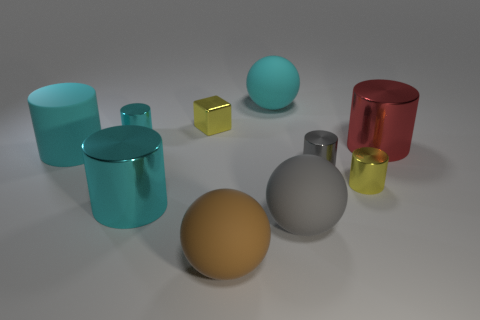There is a sphere that is on the left side of the cyan matte sphere; is its size the same as the small gray object? The sphere on the left side of the cyan matte sphere is larger than the small gray object. Specifically, the small gray object appears to be a cube, and while it's challenging to compare objects of different shapes directly, visually the sphere's diameter is certainly greater than any individual dimension of the cube. 